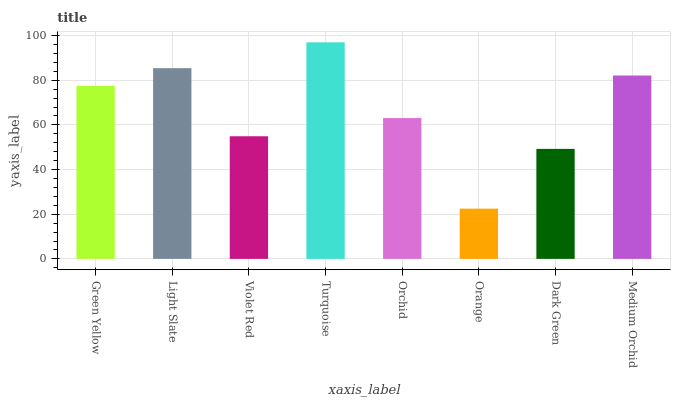Is Orange the minimum?
Answer yes or no. Yes. Is Turquoise the maximum?
Answer yes or no. Yes. Is Light Slate the minimum?
Answer yes or no. No. Is Light Slate the maximum?
Answer yes or no. No. Is Light Slate greater than Green Yellow?
Answer yes or no. Yes. Is Green Yellow less than Light Slate?
Answer yes or no. Yes. Is Green Yellow greater than Light Slate?
Answer yes or no. No. Is Light Slate less than Green Yellow?
Answer yes or no. No. Is Green Yellow the high median?
Answer yes or no. Yes. Is Orchid the low median?
Answer yes or no. Yes. Is Dark Green the high median?
Answer yes or no. No. Is Turquoise the low median?
Answer yes or no. No. 